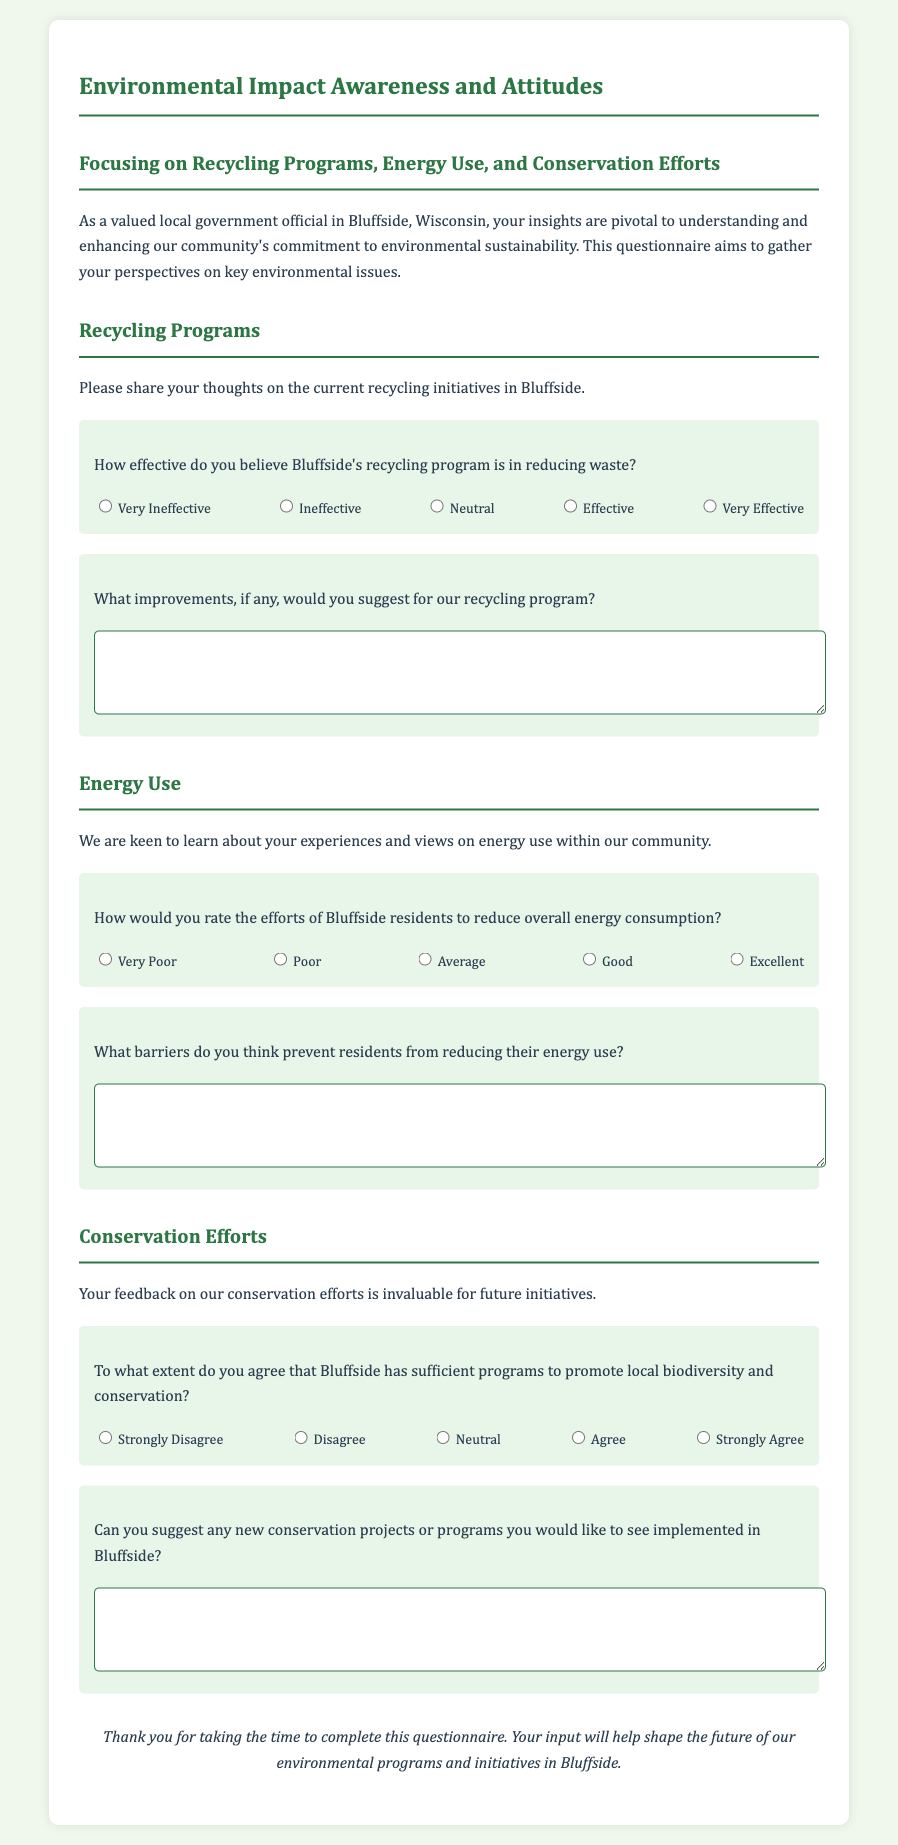What is the title of the questionnaire? The title is provided at the top of the document and indicates the main focus of the content.
Answer: Environmental Impact Awareness and Attitudes How many main sections are there in the questionnaire? The document has clear sections, each addressing different topics relevant to environmental awareness and actions.
Answer: Three What is the first question regarding recycling programs? The first question under the Recycling Programs section asks about the effectiveness of the recycling initiative.
Answer: How effective do you believe Bluffside's recycling program is in reducing waste? What scale is used to rate energy use efforts? The document presents this as a Likert scale to gauge perceptions of energy use reductions among residents.
Answer: Very Poor to Excellent What kind of response is requested for suggestions on new conservation projects? The document includes an open-ended question inviting detailed input from respondents regarding new initiatives.
Answer: A textarea for a written response How does the document categorize agreement regarding conservation programs? The document utilizes a Likert scale for respondents to express their levels of agreement about the adequacy of conservation programs.
Answer: Strongly Disagree to Strongly Agree What kind of barriers does the energy use question inquire about? The inquiry focuses on understanding factors that may limit residents' ability to decrease energy consumption.
Answer: Barriers preventing energy reduction What type of feedback is the questionnaire collecting overall? The questionnaire seeks qualitative insights from local government officials to assess and enhance community environmental initiatives.
Answer: Input on environmental programs and initiatives What is the last section of the questionnaire about? The final section focuses on gathering views related to conservation efforts, indicating its lineage from the previous sections.
Answer: Conservation Efforts 